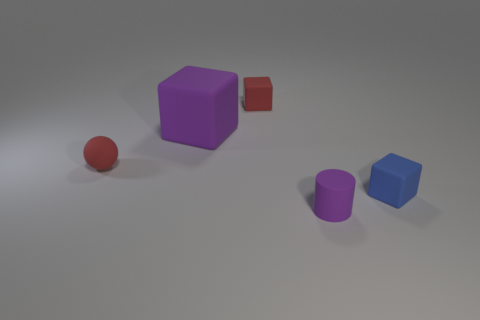Add 4 large cubes. How many objects exist? 9 Subtract all spheres. How many objects are left? 4 Subtract all big purple rubber spheres. Subtract all red cubes. How many objects are left? 4 Add 1 cubes. How many cubes are left? 4 Add 1 tiny red cubes. How many tiny red cubes exist? 2 Subtract 0 gray blocks. How many objects are left? 5 